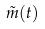<formula> <loc_0><loc_0><loc_500><loc_500>\tilde { m } ( t )</formula> 